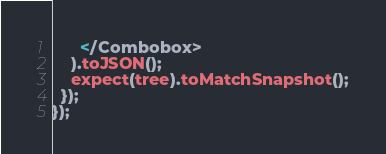<code> <loc_0><loc_0><loc_500><loc_500><_JavaScript_>      </Combobox>
    ).toJSON();
    expect(tree).toMatchSnapshot();
  });
});
</code> 